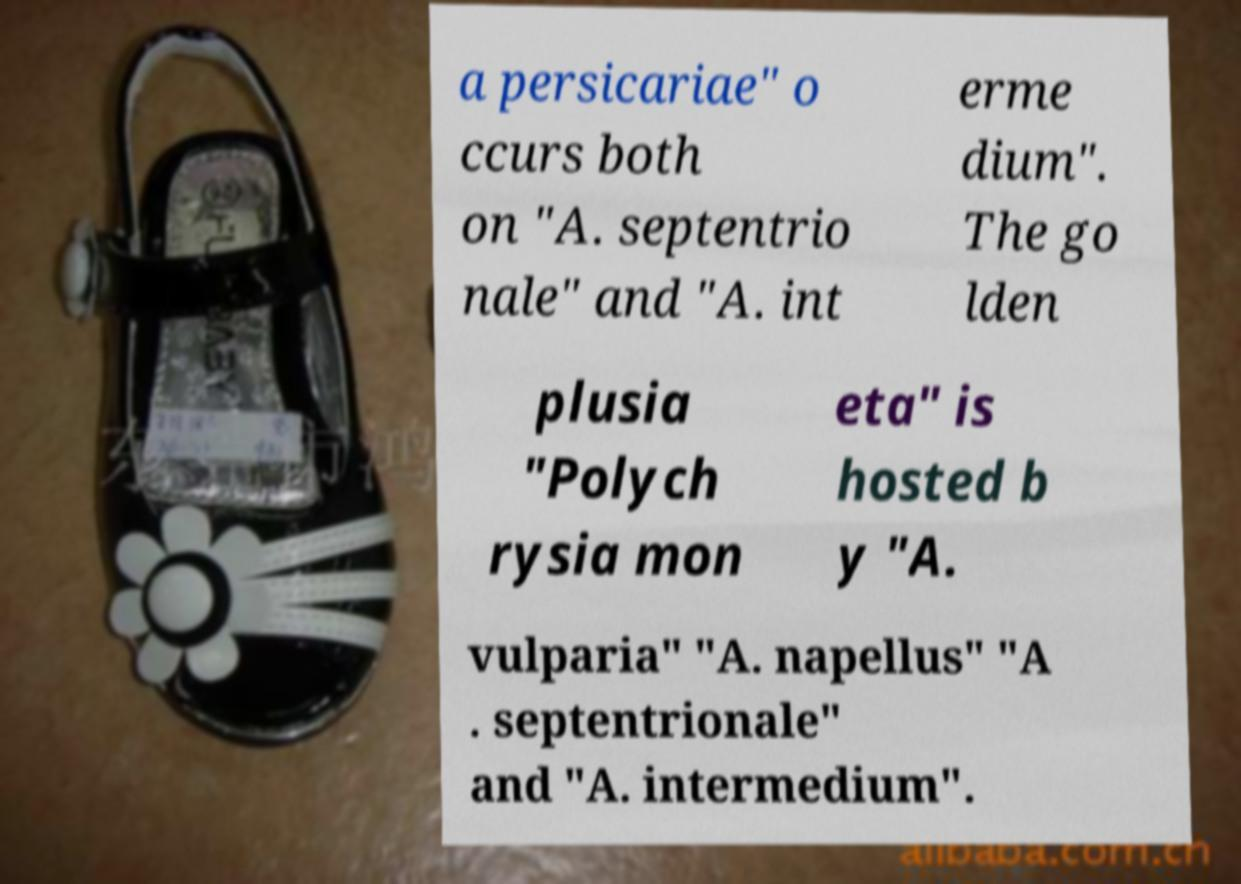Can you accurately transcribe the text from the provided image for me? a persicariae" o ccurs both on "A. septentrio nale" and "A. int erme dium". The go lden plusia "Polych rysia mon eta" is hosted b y "A. vulparia" "A. napellus" "A . septentrionale" and "A. intermedium". 